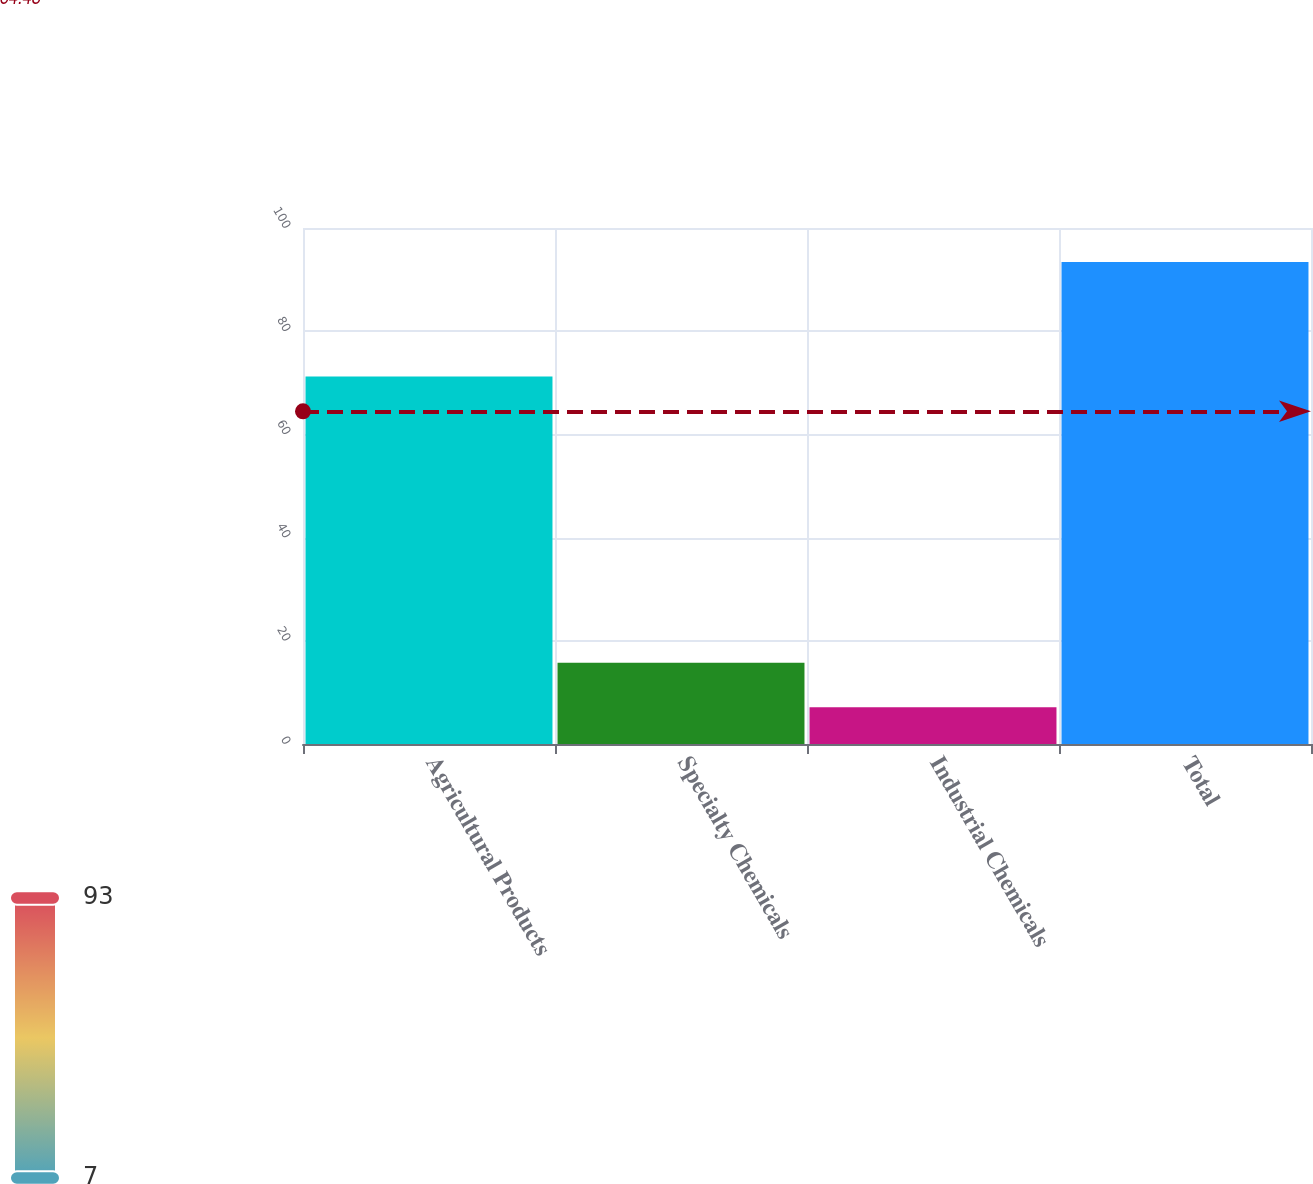Convert chart to OTSL. <chart><loc_0><loc_0><loc_500><loc_500><bar_chart><fcel>Agricultural Products<fcel>Specialty Chemicals<fcel>Industrial Chemicals<fcel>Total<nl><fcel>71.2<fcel>15.73<fcel>7.1<fcel>93.4<nl></chart> 